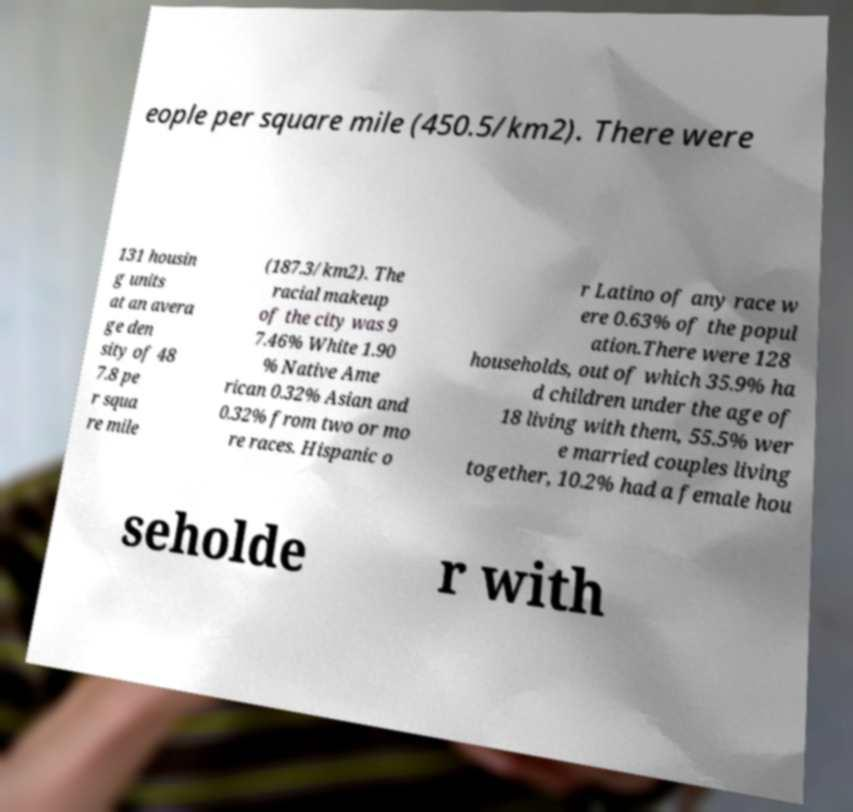Please identify and transcribe the text found in this image. eople per square mile (450.5/km2). There were 131 housin g units at an avera ge den sity of 48 7.8 pe r squa re mile (187.3/km2). The racial makeup of the city was 9 7.46% White 1.90 % Native Ame rican 0.32% Asian and 0.32% from two or mo re races. Hispanic o r Latino of any race w ere 0.63% of the popul ation.There were 128 households, out of which 35.9% ha d children under the age of 18 living with them, 55.5% wer e married couples living together, 10.2% had a female hou seholde r with 